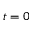<formula> <loc_0><loc_0><loc_500><loc_500>t = 0</formula> 